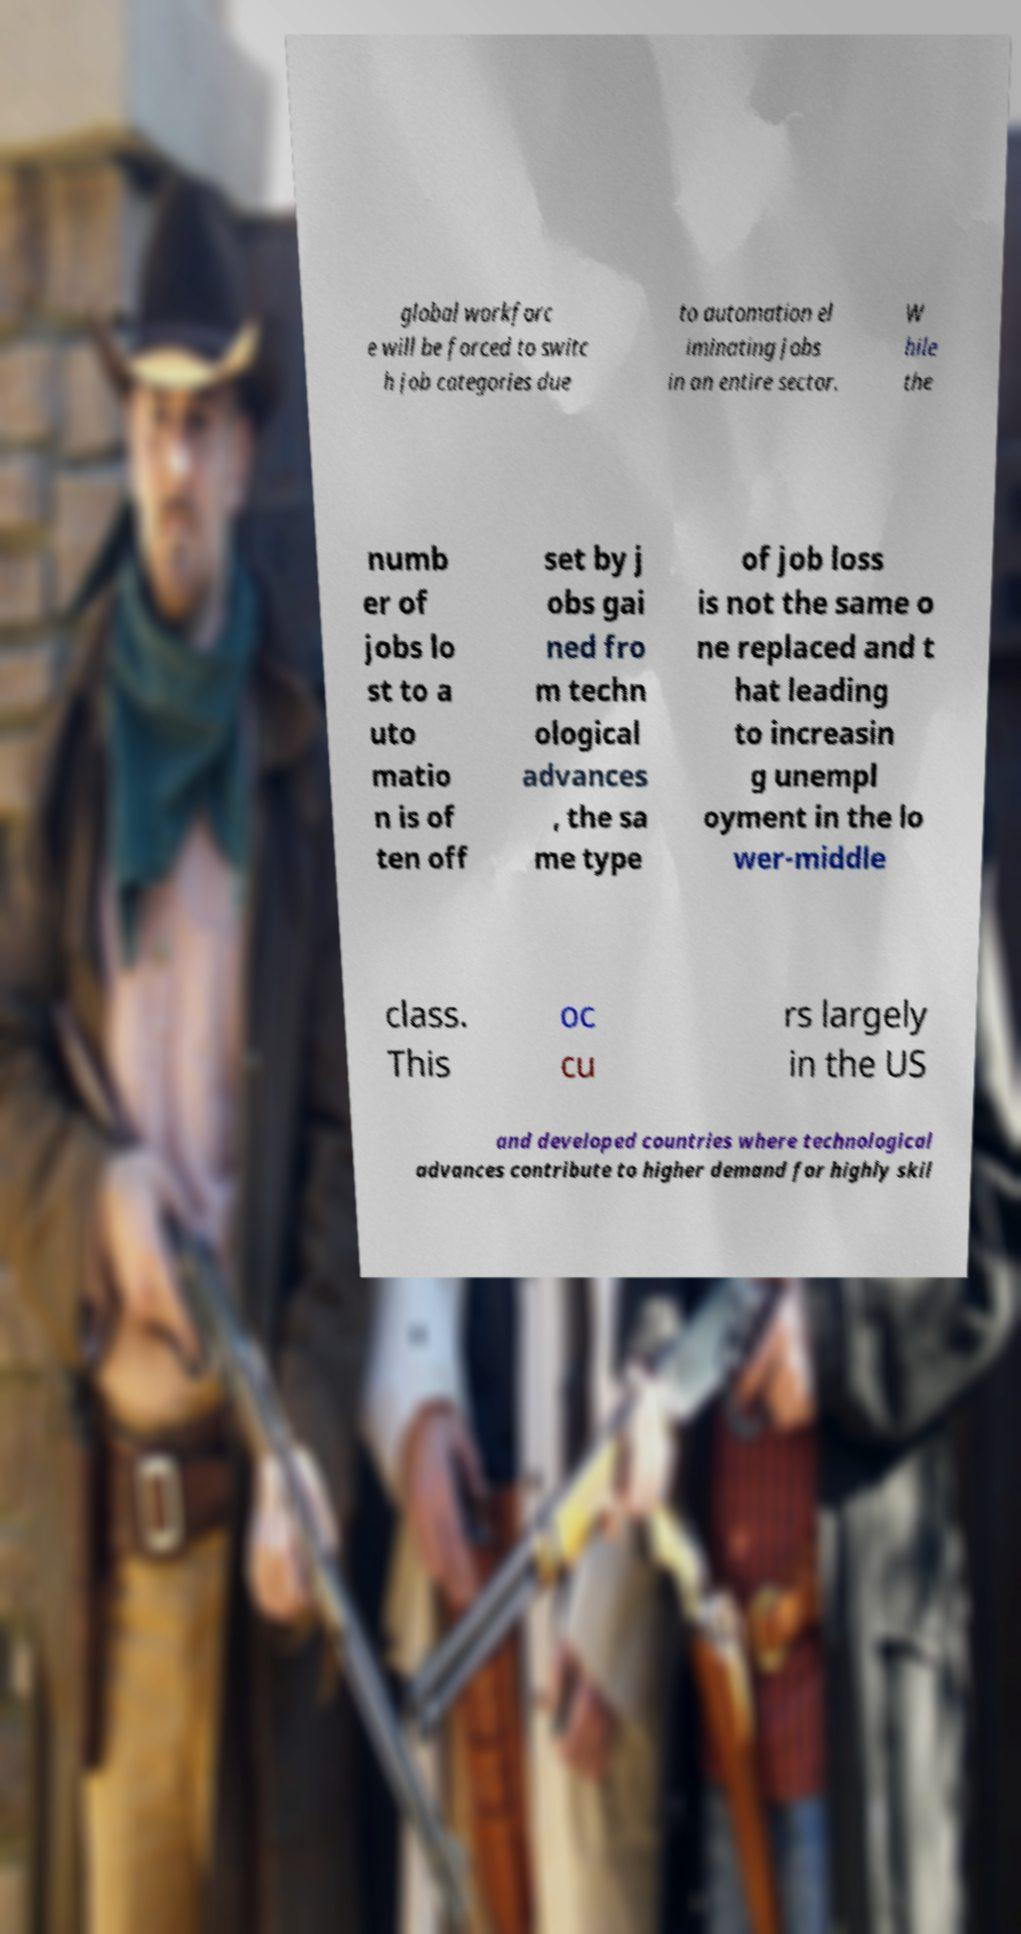Please identify and transcribe the text found in this image. global workforc e will be forced to switc h job categories due to automation el iminating jobs in an entire sector. W hile the numb er of jobs lo st to a uto matio n is of ten off set by j obs gai ned fro m techn ological advances , the sa me type of job loss is not the same o ne replaced and t hat leading to increasin g unempl oyment in the lo wer-middle class. This oc cu rs largely in the US and developed countries where technological advances contribute to higher demand for highly skil 